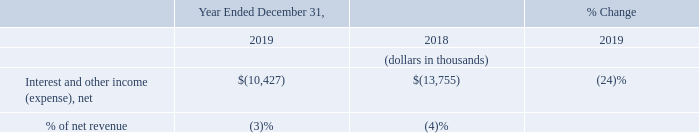Interest and Other Income (Expense)
Interest and other income (expense), net changed by $3.3 million from a net expense of $13.8 million in the year ended December 31, 2018 to a net expense of $10.4 million for the year ended December 31, 2019. The change in interest and other income (expense), net was primarily due to a decrease in interest expense pertaining to a lower average balance of debt outstanding under our term loan facility during the year.
What was the net expense in the year ended December 31, 2018? $13.8 million. What was the net expense in the year ended December 31, 2019? $10.4 million. What led to change in interest and other income (expense), net? Primarily due to a decrease in interest expense pertaining to a lower average balance of debt outstanding under our term loan facility during the year. What is the average Interest and other income (expense), net for the year ended December 31, 2019 to 2018?
Answer scale should be: thousand. -(10,427+13,755) / 2
Answer: -12091. What is the average % of net revenue for the year ended December 31, 2019 to 2018?
Answer scale should be: percent. (3+4) / 2
Answer: 3.5. What is the change in Interest and other income (expense), net from the year ended December 31, 2019 to 2018?
Answer scale should be: thousand. -10,427-(13,755)
Answer: 3328. 